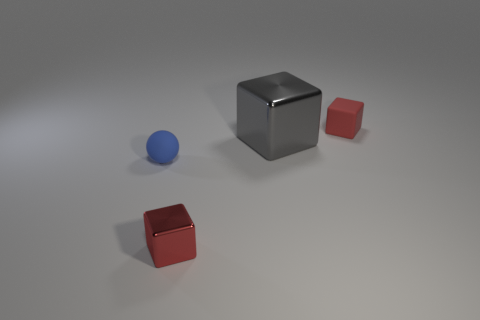There is a rubber sphere that is the same size as the red metal thing; what color is it?
Your response must be concise. Blue. There is a rubber sphere that is to the left of the tiny red thing that is on the left side of the matte block; how big is it?
Your response must be concise. Small. What size is the other thing that is the same color as the tiny metallic thing?
Ensure brevity in your answer.  Small. How many other things are there of the same size as the gray block?
Keep it short and to the point. 0. How many matte cubes are there?
Offer a very short reply. 1. Do the red matte block and the red shiny cube have the same size?
Offer a terse response. Yes. How many other things are the same shape as the small red metal object?
Your response must be concise. 2. The red thing that is in front of the tiny cube behind the tiny blue sphere is made of what material?
Ensure brevity in your answer.  Metal. There is a gray cube; are there any tiny things in front of it?
Give a very brief answer. Yes. Is the size of the red rubber cube the same as the object that is on the left side of the tiny red metal object?
Ensure brevity in your answer.  Yes. 